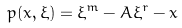<formula> <loc_0><loc_0><loc_500><loc_500>p ( x , \xi ) = \xi ^ { m } - A \xi ^ { r } - x</formula> 